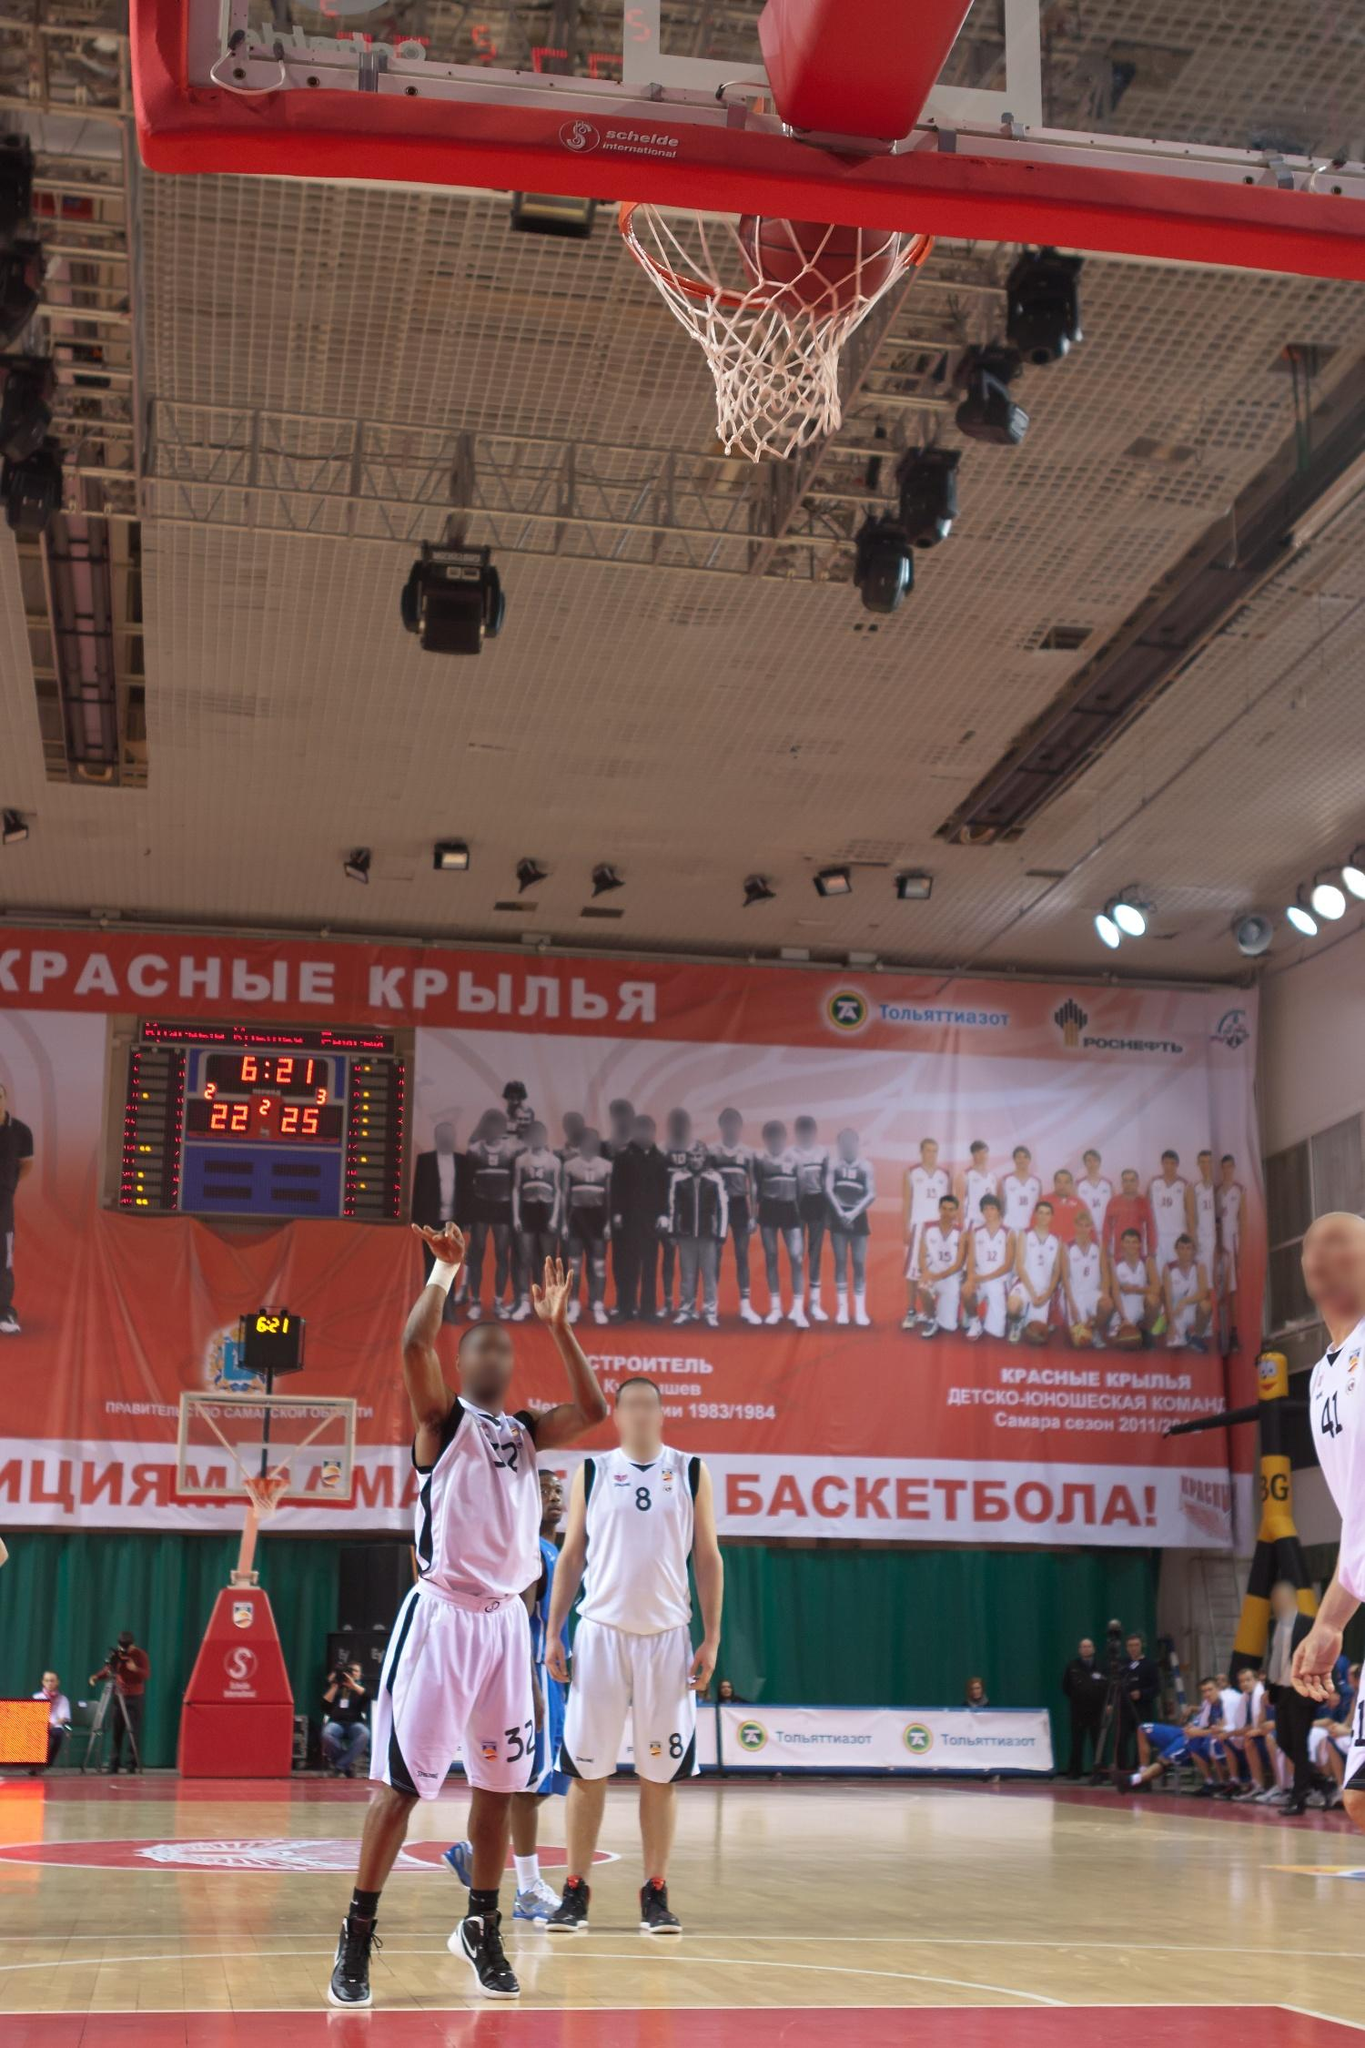Can you provide a detailed analysis of this basketball court setup and its impact on the game? The basketball court depicted in this image is meticulously set up to ensure an optimal environment for competitive play. The court's polished wooden floor is standard, allowing for high-performance movement and minimal injury risk, which is crucial for both players and officials. The distinctive red and white markings clearly define the key areas—like the three-point line, free throw line, and key—facilitating precise gameplay regulations.

Visual elements such as banners and advertisements around the court not only enhance the aesthetic appeal but also represent the team's identity and sponsors, creating an immersive experience for everyone present. The prominent banner with "Красные крылья," translating to "Red Wings," likely indicates the home team's branding, bolstering fan support and atmosphere.

Lighting plays a significant role, with bright, uniformly distributed lights ensuring the court is well-illuminated, reducing shadows and enhancing visibility for players, referees, and spectators. The scoreboard is strategically positioned for maximum visibility, providing crucial real-time updates on the game’s status, like time remaining and current scores. This immediate feedback is vital for players to adjust their strategies accordingly.

The arrangement of the players shown, with careful positioning off-ball, indicates a structured offense and defense, essential for coordinated team play. The coaches and contextual staff on the sidelines reflect an organized and professional managed event, ready to intervene when necessary. The overall setup of the court thus enhances the quality of the game, ensuring fair play, optimal performance, and engaging viewing experience, positively impacting the outcome and enjoyment of the event. 